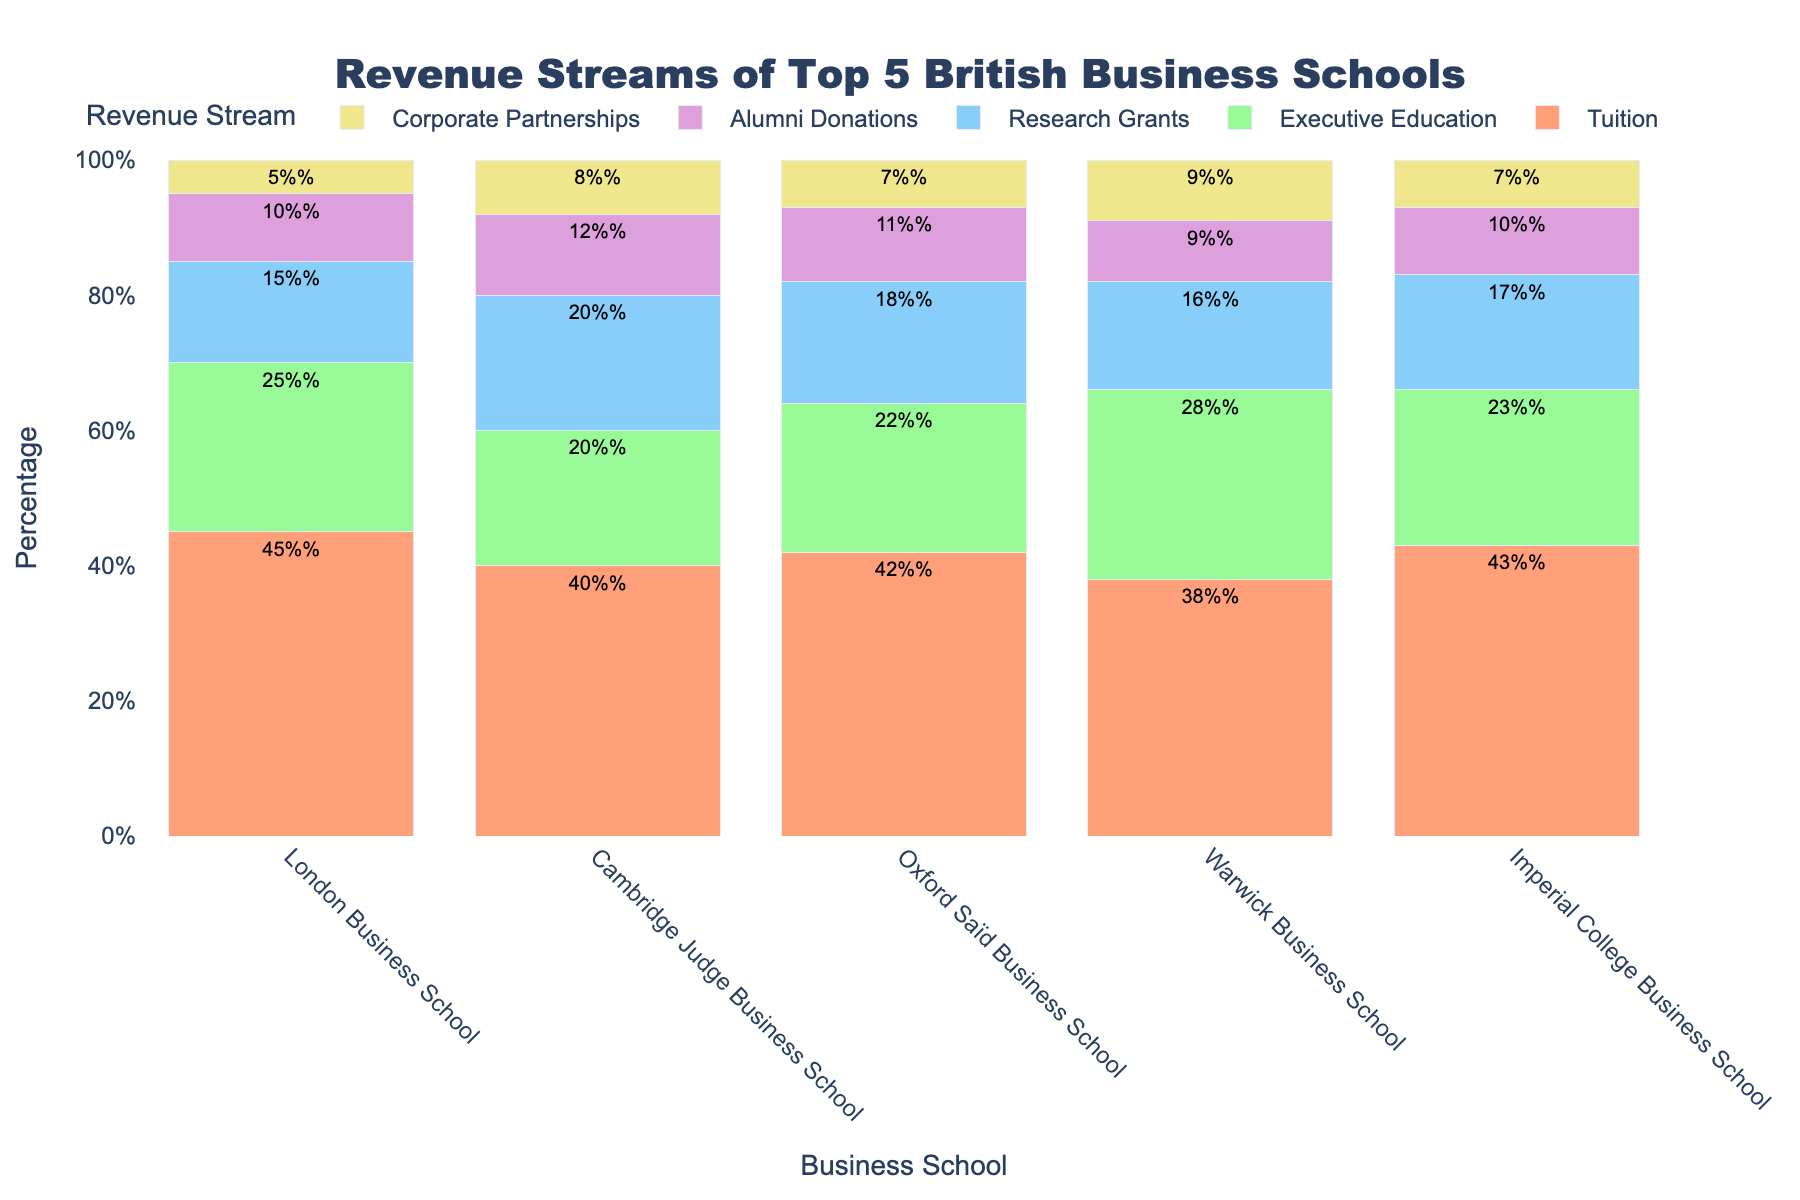Which school has the highest percentage of revenue from Executive Education? The 'Executive Education' bar with the greatest height represents the highest percentage. Warwick Business School has the tallest bar for Executive Education at 28%.
Answer: Warwick Business School Which school has the lowest percentage of revenue from Alumni Donations? The 'Alumni Donations' bar with the shortest height represents the lowest percentage. Warwick Business School has the shortest bar for Alumni Donations at 9%.
Answer: Warwick Business School What is the combined percentage of revenue from Research Grants and Alumni Donations for Oxford Saïd Business School? Add the percentages from Research Grants (18%) and Alumni Donations (11%) for Oxford Saïd Business School. The combined percentage is 18 + 11 = 29%.
Answer: 29% Which revenue stream contributes the least to Cambridge Judge Business School's total revenue? Identify the bar with the smallest height for Cambridge Judge Business School. The 'Corporate Partnerships' bar is the shortest at 8%.
Answer: Corporate Partnerships Compare the percentage of revenue from Tuition between Imperial College Business School and Cambridge Judge Business School. Which one is higher? Compare the heights of the 'Tuition' bars for Imperial College Business School (43%) and Cambridge Judge Business School (40%). Imperial College Business School has the higher percentage.
Answer: Imperial College Business School What is the range of percentages for Corporate Partnerships across all schools? Identify the minimum and maximum values of the 'Corporate Partnerships' percentages. The range is 5% (London Business School) to 9% (Warwick Business School).
Answer: 5% to 9% How does the total percentage of Alumni Donations compare between Cambridge Judge Business School and Imperial College Business School? Compare the 'Alumni Donations' percentages. Cambridge Judge Business School has 12%, and Imperial College Business School has 10%. Cambridge Judge Business School has a higher percentage of Alumni Donations.
Answer: Cambridge Judge Business School Which school has the most evenly distributed revenue streams (i.e., smallest difference between the highest and lowest percentages)? Calculate the difference between the highest and lowest values for each school. For London Business School: 45% - 5% = 40%, Cambridge Judge: 40% - 8% = 32%, Oxford Saïd: 42% - 7% = 35%, Warwick: 38% - 9% = 29%, Imperial College: 43% - 7% = 36%. Warwick Business School has the smallest difference (29%).
Answer: Warwick Business School Which two schools have the closest percentages for Executive Education? Compare the 'Executive Education' percentages for each pair of schools. The closest are London Business School (25%) and Imperial College Business School (23%) which differ by 2%.
Answer: London Business School and Imperial College Business School 